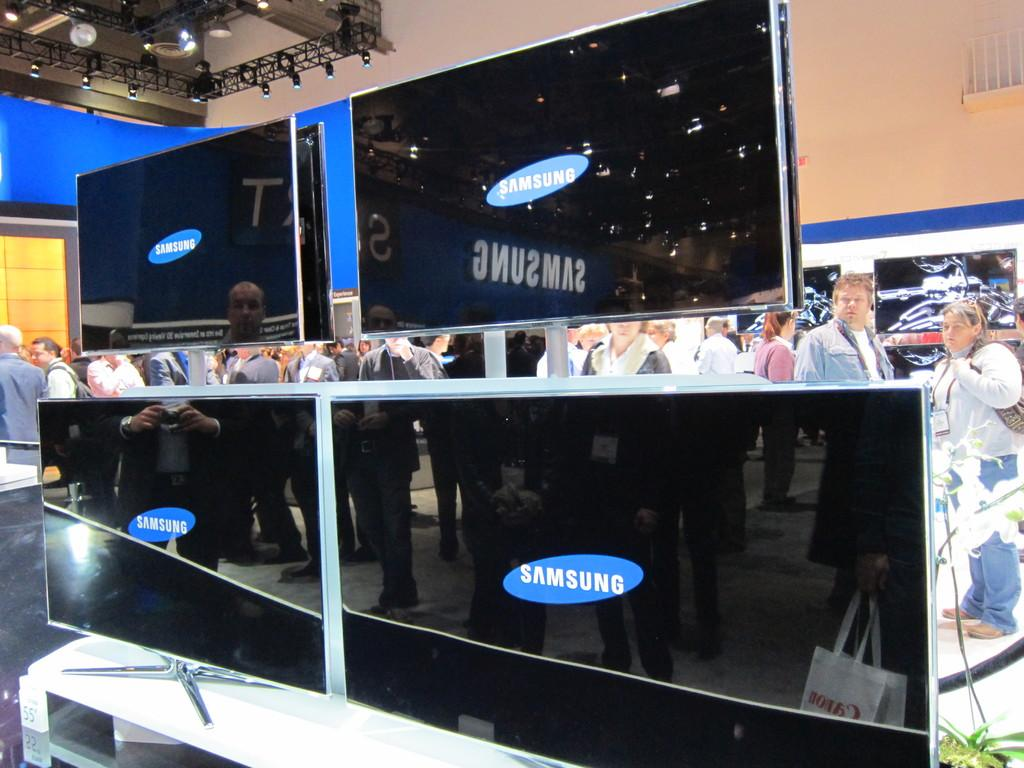<image>
Offer a succinct explanation of the picture presented. A group of people at a convention are looking at flat screen TVs that say Samsung. 